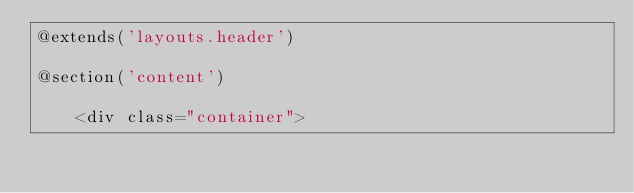Convert code to text. <code><loc_0><loc_0><loc_500><loc_500><_PHP_>@extends('layouts.header')

@section('content')

    <div class="container"></code> 